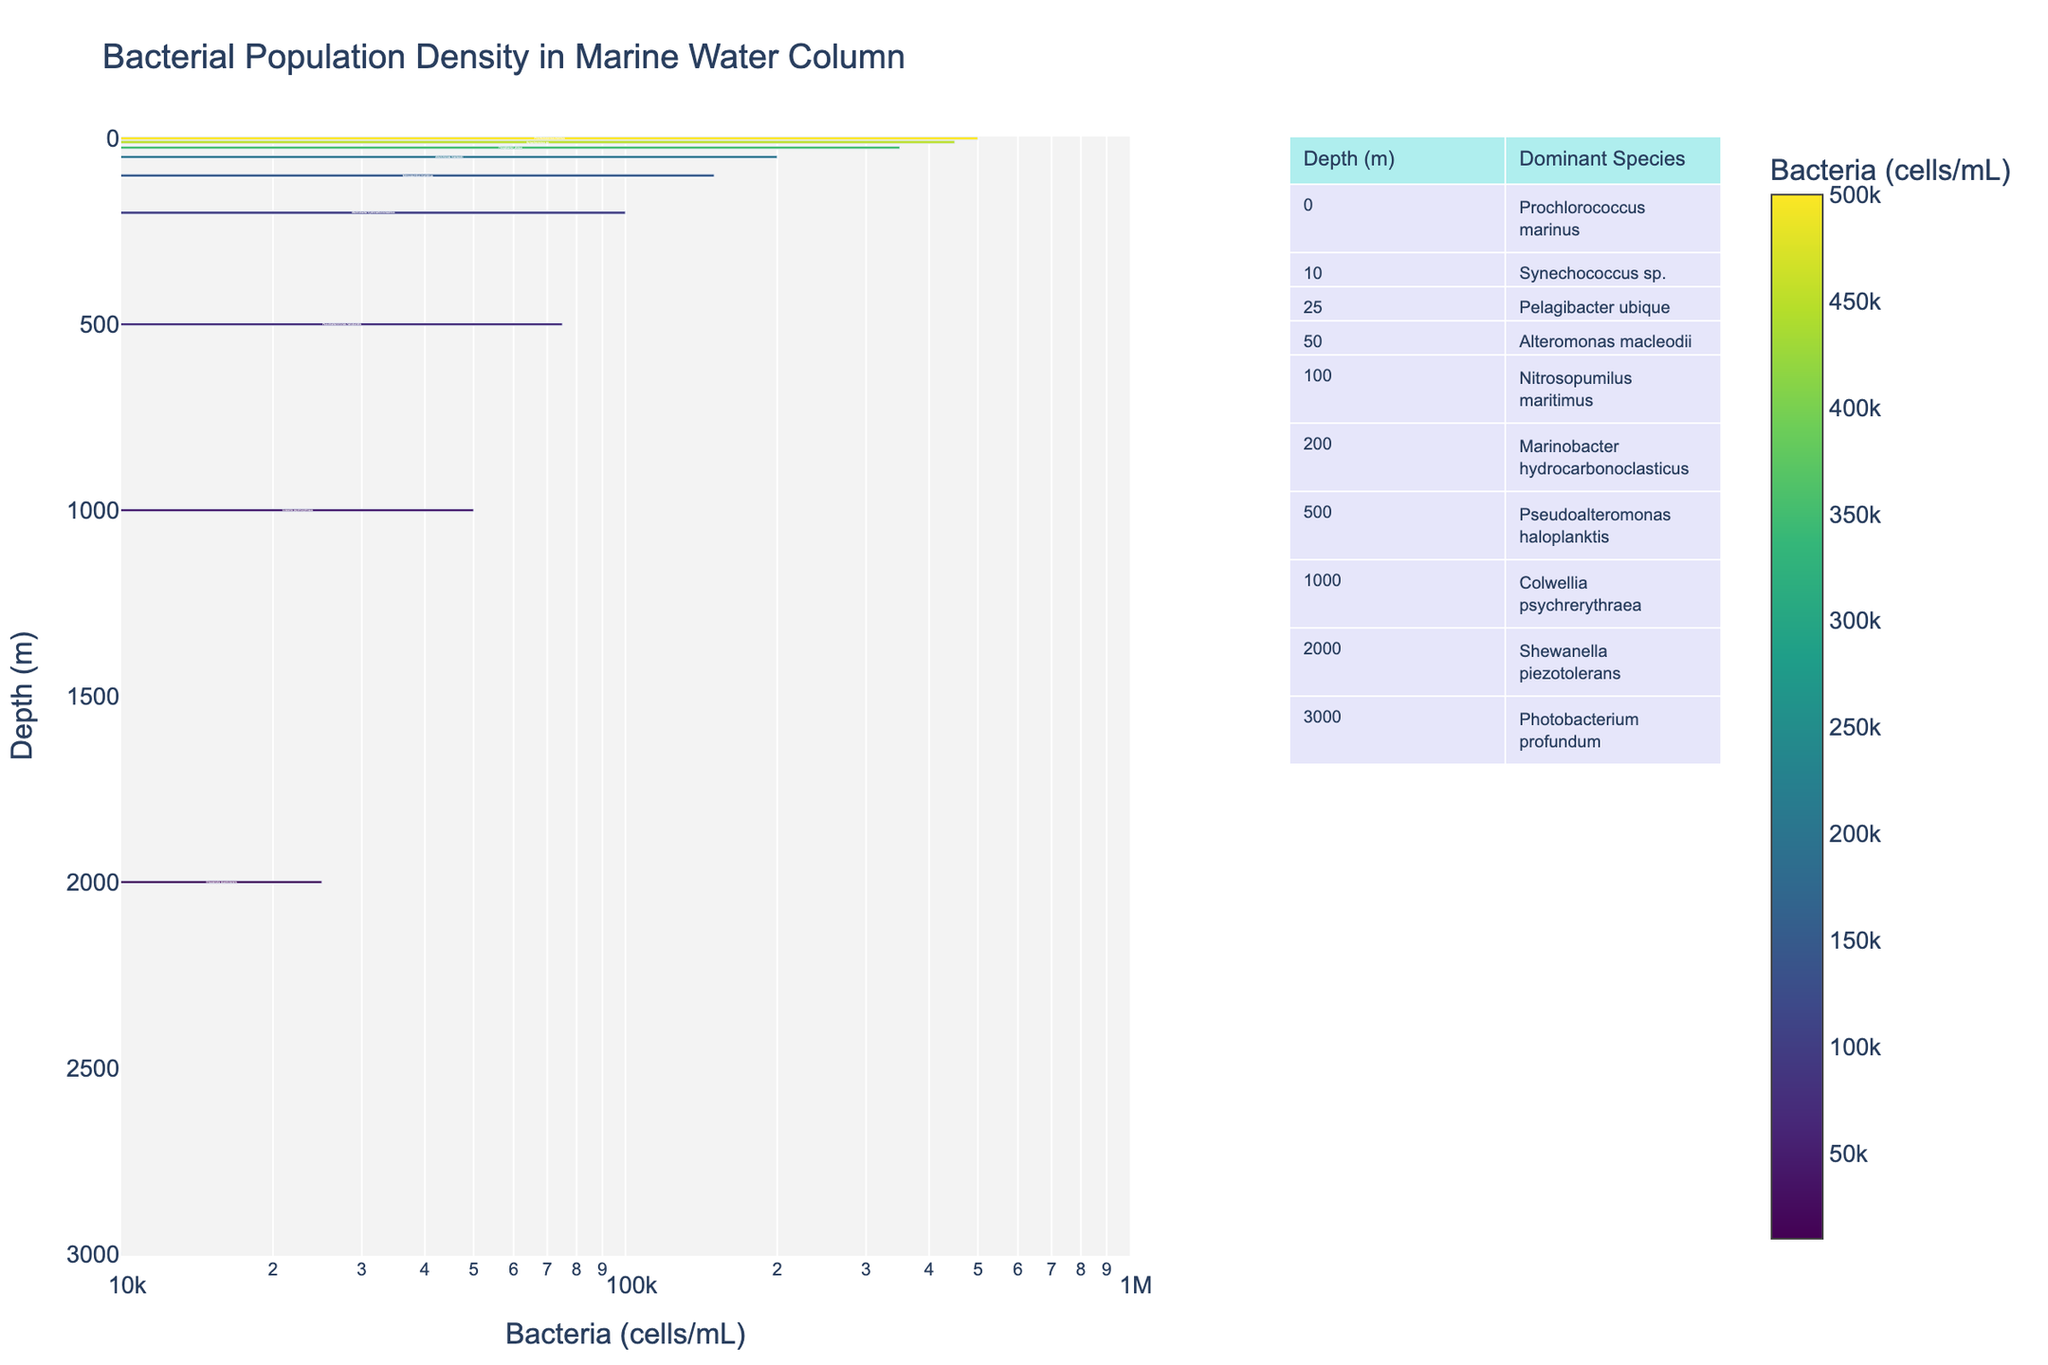Which depth has the highest bacterial population density? The bar chart shows population densities; the bar for 0 meters has the highest value, indicating the highest bacterial population density.
Answer: 0 meters Which species is dominant at 1000 meters depth? According to the table beside the chart, Colwellia psychrerythraea is the dominant species at 1000 meters depth.
Answer: Colwellia psychrerythraea What is the difference in bacterial population density between 10 meters and 100 meters depth? The bar chart indicates 450,000 cells/mL at 10 meters and 150,000 cells/mL at 100 meters. The difference is 450,000 - 150,000 = 300,000 cells/mL.
Answer: 300,000 cells/mL Which depth has the shortest bar in the bar chart? The bar chart displays 3000 meters as having the shortest bar, representing the lowest bacterial population density.
Answer: 3000 meters What is the average bacterial population density from the surface to 50 meters depth? Depths to consider are 0, 10, 25, and 50 meters. The population densities are 500,000, 450,000, 350,000, and 200,000 cells/mL. The average is (500,000 + 450,000 + 350,000 + 200,000) / 4 = 1,500,000 / 4 = 375,000 cells/mL.
Answer: 375,000 cells/mL Is the bacterial population density at 2000 meters greater than that at 3000 meters? The bar chart shows 25,000 cells/mL at 2000 meters and 10,000 cells/mL at 3000 meters, indicating that the population density at 2000 meters is greater.
Answer: Yes Which layer of the water column has a bacterial population density of 75,000 cells/mL? The bar chart reveals that 500 meters depth has a bacterial population density of 75,000 cells/mL.
Answer: 500 meters How does the bacterial population density trend as depth increases? Observing the bar chart, the bacterial population density generally decreases as the depth increases.
Answer: Decreases 